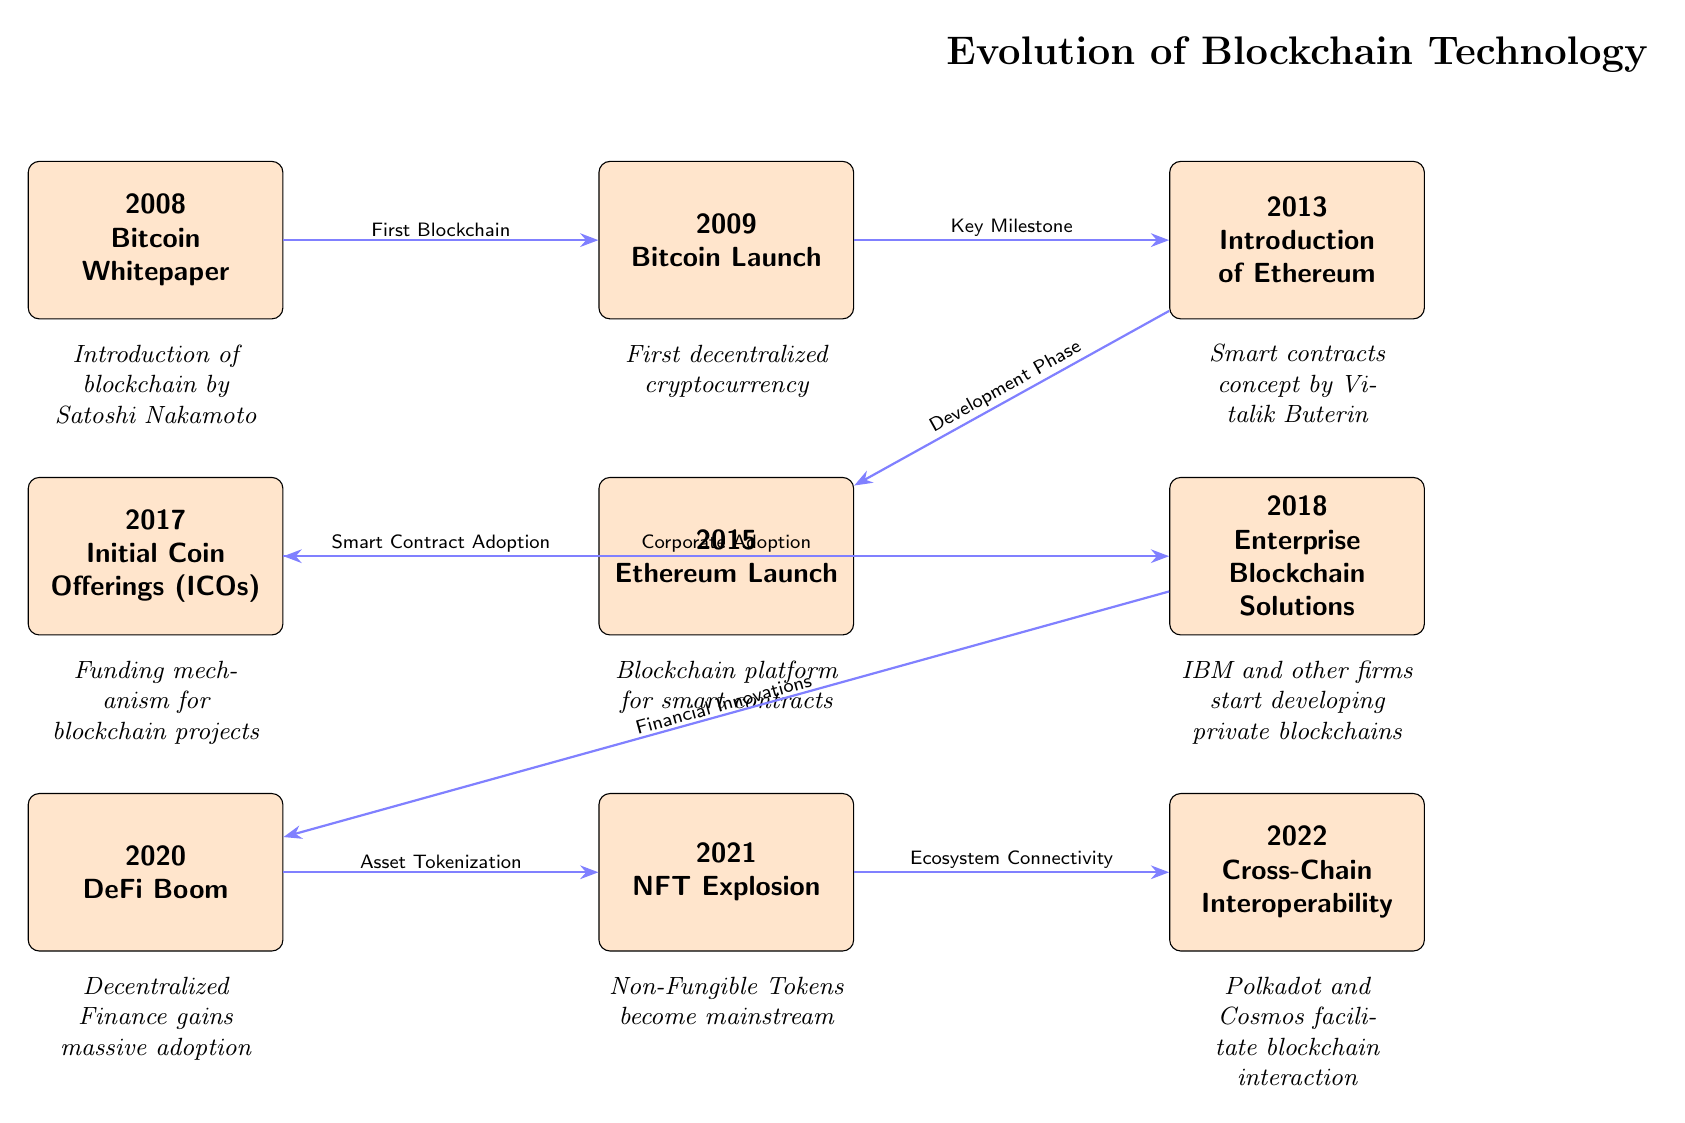What year was the Bitcoin Whitepaper released? The diagram indicates that the Bitcoin Whitepaper was released in 2008, as shown by the node labeled "2008 - Bitcoin Whitepaper."
Answer: 2008 What is the significance of the node labeled 2013? The 2013 node is significant because it introduces Ethereum, as stated in the description "Smart contracts concept by Vitalik Buterin," making it a pivotal year for blockchain development.
Answer: Introduction of Ethereum How many key developments are highlighted in the diagram? By counting the nodes representing key developments, we find a total of eight events from 2008 to 2022, which are the distinct points of significance in blockchain evolution.
Answer: Eight Which development directly follows the launch of Ethereum in 2015? According to the diagram, the development that directly follows the launch of Ethereum in 2015 is the "Initial Coin Offerings (ICOs)" in 2017, as indicated by the arrow connecting those two nodes.
Answer: Initial Coin Offerings (ICOs) What major trend occurred in 2020 following the advent of cryptocurrencies? The diagram highlights the "DeFi Boom" in 2020 as the major trend, illustrating a significant shift toward decentralized finance after the introduction of cryptocurrencies.
Answer: DeFi Boom What does the arrow between 2018 and 2020 represent? The arrow connecting the events in 2018 to 2020 signifies a flow from "Enterprise Blockchain Solutions" to "DeFi Boom," indicating that developments in enterprise solutions influenced the rise of decentralized finance.
Answer: Financial Innovations How does the concept of cross-chain interoperability relate to previous innovations? The node labeled "Cross-Chain Interoperability" in 2022 follows the "NFT Explosion" in 2021, suggesting a logical evolution in blockchain technology that enhances the interconnectedness of different blockchain ecosystems.
Answer: Ecosystem Connectivity What is the first significant event in the timeline? The first significant event in the timeline is the release of the Bitcoin Whitepaper in 2008, marking the beginning of blockchain technology as represented by the first node on the left.
Answer: Bitcoin Whitepaper 